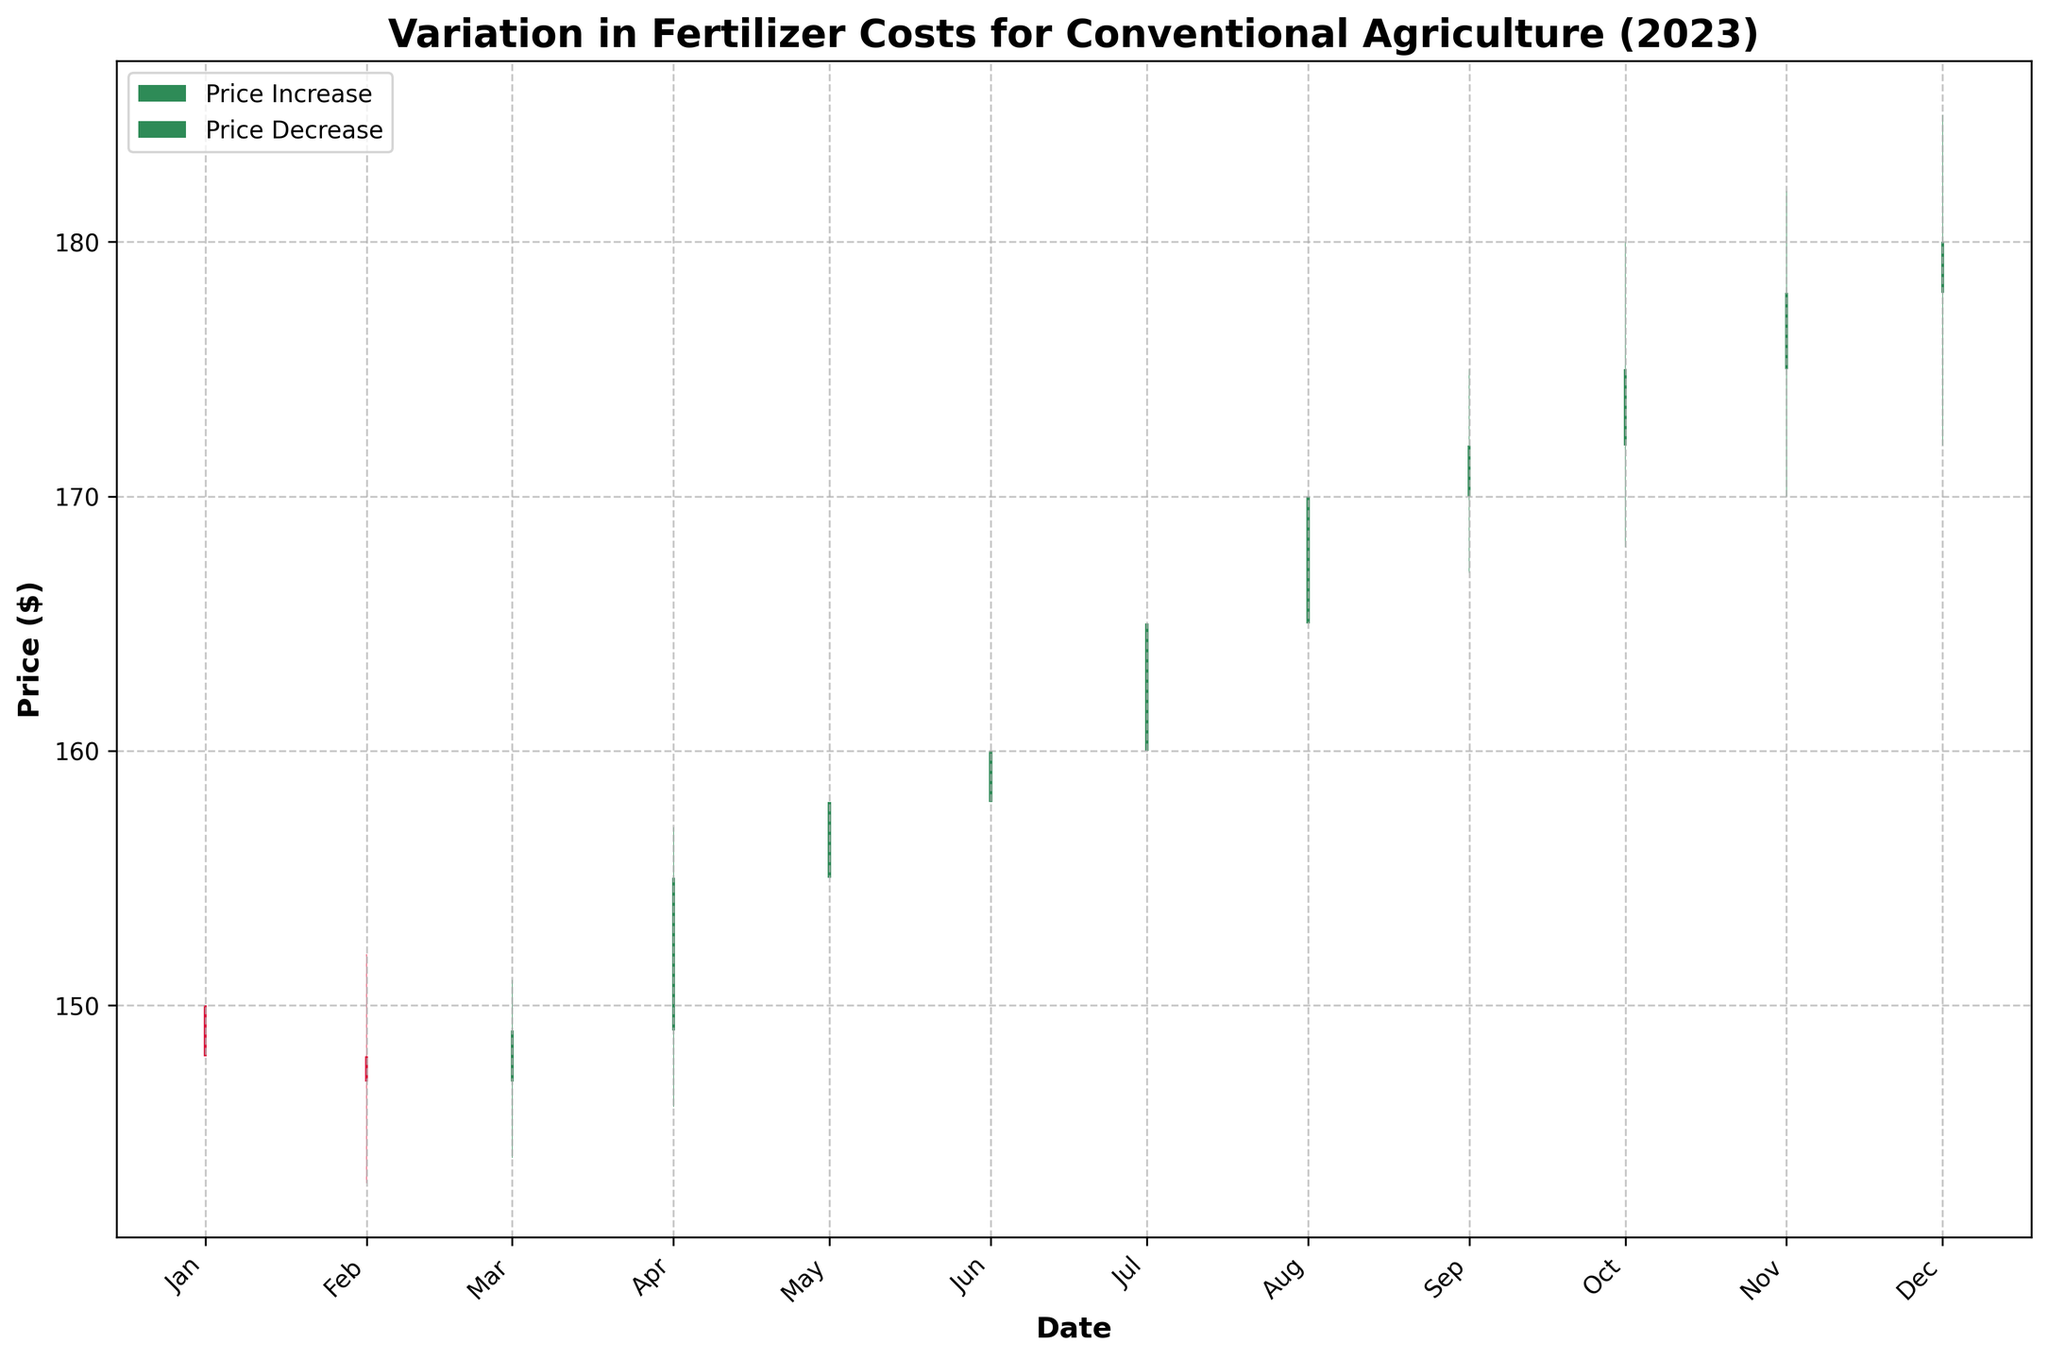What's the title of the figure? The title of the figure is displayed at the top center of the chart.
Answer: Variation in Fertilizer Costs for Conventional Agriculture (2023) What does the x-axis represent? The x-axis represents the dates, with each tick marking a different month of the year.
Answer: Date How are price increases visually represented in the chart? Price increases are shown using green-colored candlesticks.
Answer: Green candlesticks Which month shows the highest closing price? To find the month with the highest closing price, examine the topmost part of the green and red candlesticks and identify the month where the highest bar is located.
Answer: December In which month did the price decrease compared to its opening price? To determine this, look for red candlesticks which indicate that the closing price was lower than the opening price.
Answer: February Which months had the largest variation between high and low prices? The months with the longest candlestick wicks (lines above and below the body) represent the largest variations. Identify these months by comparing the lengths of the wicks.
Answer: October Compare the opening price in January and July. Which one was higher? Compare the bottom of the candlestick bodies for January and July. The higher the bottom, the higher the opening price.
Answer: July What is the closing price for September? Look at the top of the candlestick body marked for September to find the closing price.
Answer: 172 Which month shows an increasing trend where the opening price was lower than the closing price in consecutive months? To identify this, look for a consecutive pattern of green candlesticks starting from a particular month.
Answer: August to December What was the price range (difference between high and low) in April? Subtract the lowest price in April from the highest price to determine the price range. The high was 157 and the low was 146.
Answer: 11 